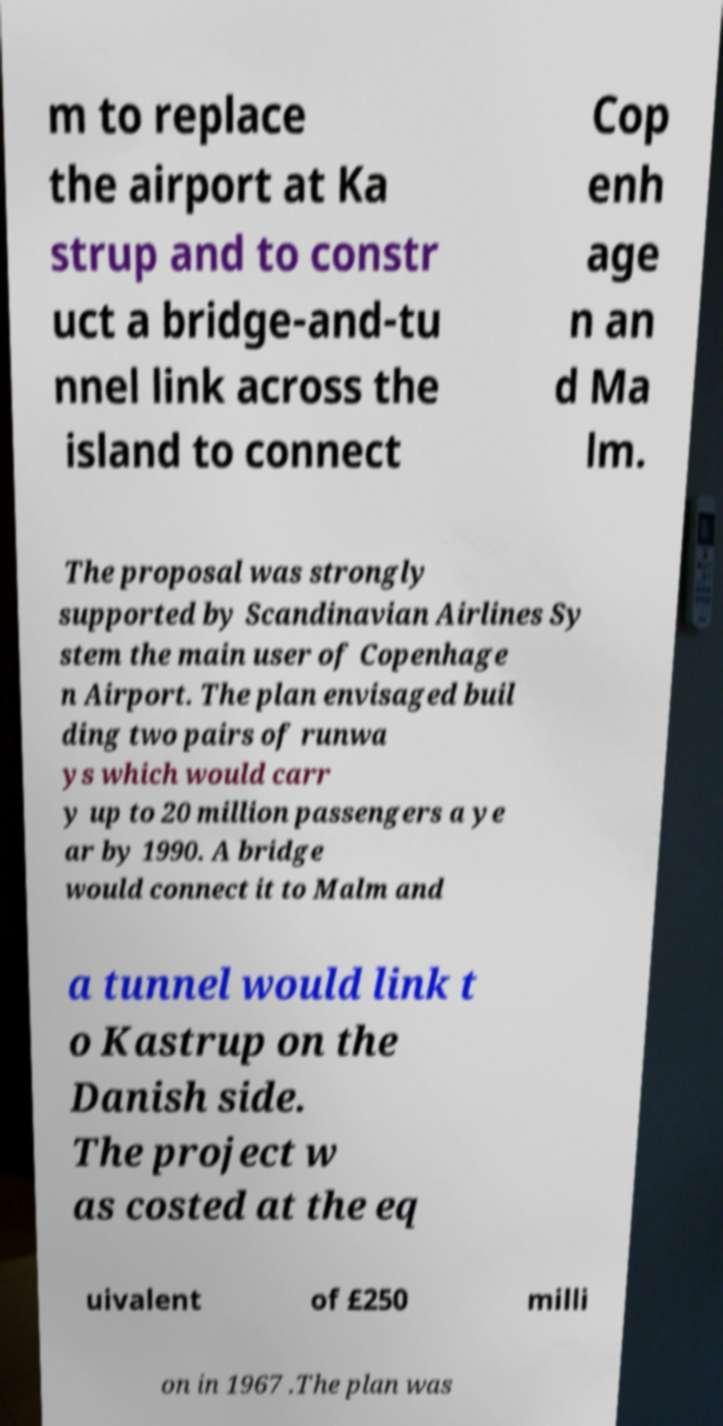For documentation purposes, I need the text within this image transcribed. Could you provide that? m to replace the airport at Ka strup and to constr uct a bridge-and-tu nnel link across the island to connect Cop enh age n an d Ma lm. The proposal was strongly supported by Scandinavian Airlines Sy stem the main user of Copenhage n Airport. The plan envisaged buil ding two pairs of runwa ys which would carr y up to 20 million passengers a ye ar by 1990. A bridge would connect it to Malm and a tunnel would link t o Kastrup on the Danish side. The project w as costed at the eq uivalent of £250 milli on in 1967 .The plan was 